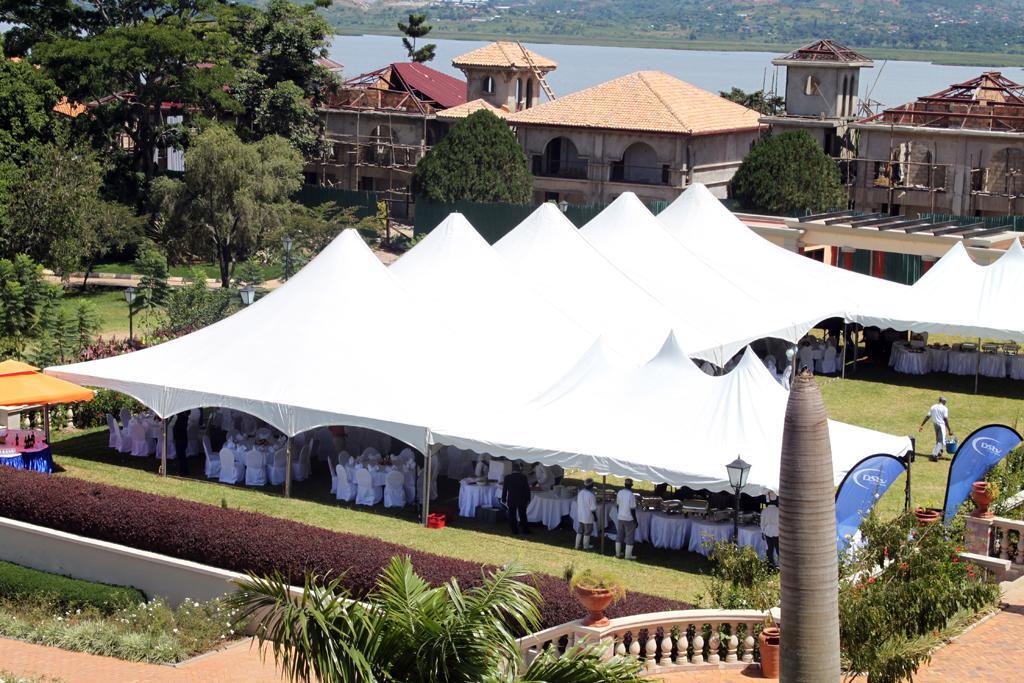How would you summarize this image in a sentence or two? In this image we can see the buildings, in front of the buildings we can see there are tents and in that there are tables with a cloth and chairs. And there are a few objects on the table. And there are trees, light poles, railing, grass, water and plants with flower. And there are potted plants and it looks like a palm. 